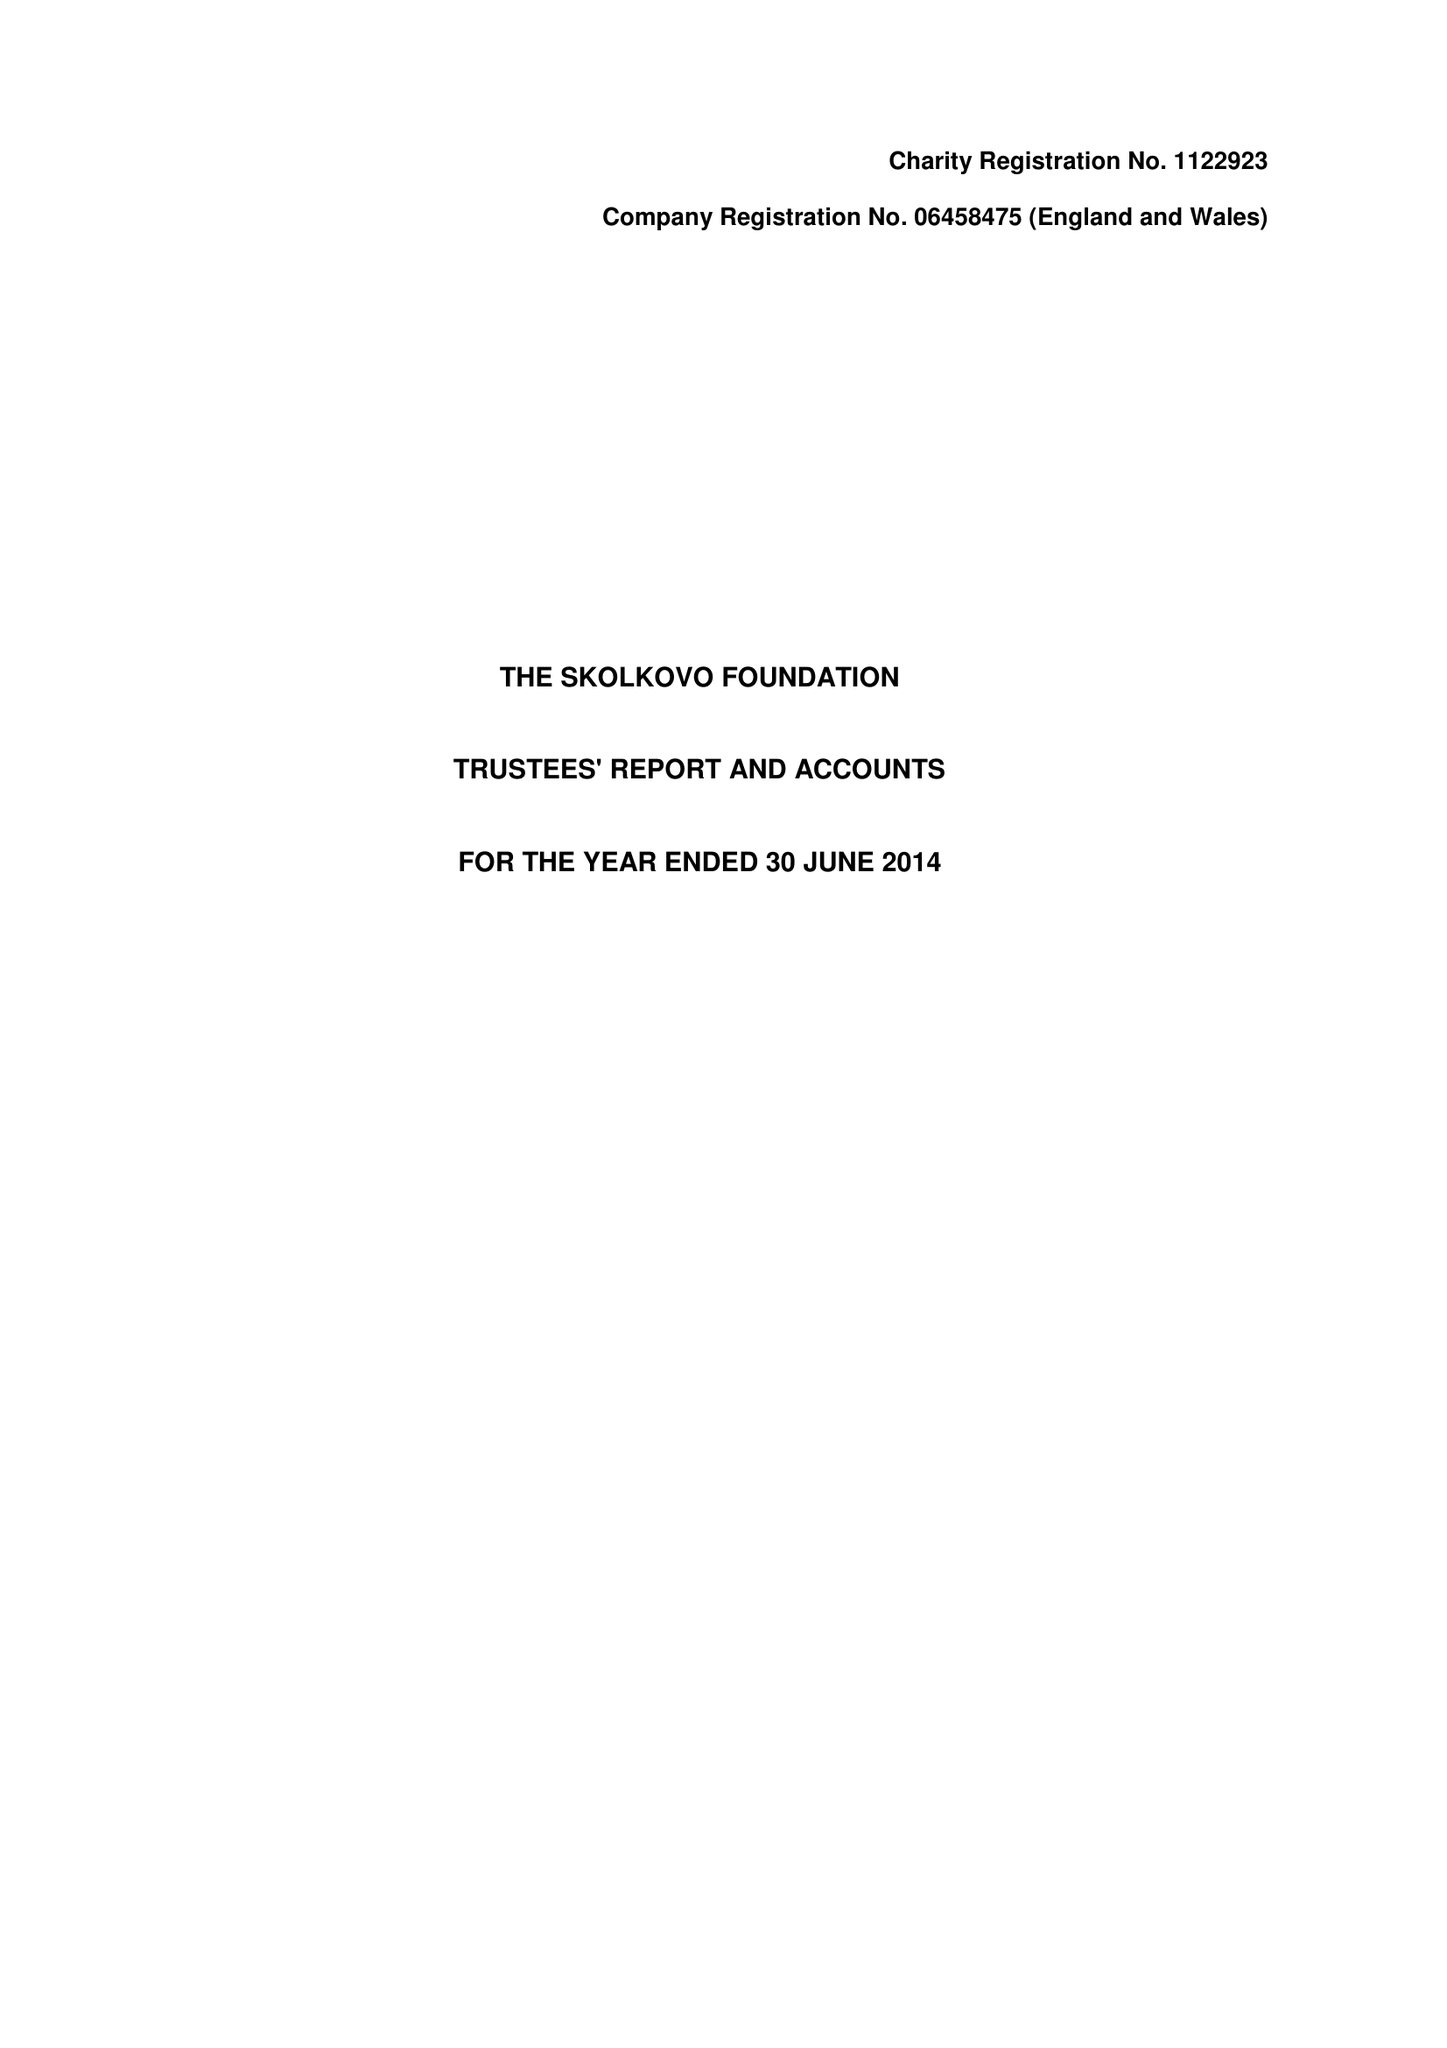What is the value for the charity_name?
Answer the question using a single word or phrase. The Skolkovo Foundation 